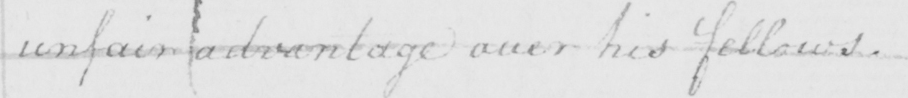Please provide the text content of this handwritten line. unfair advantage over his fellows . 